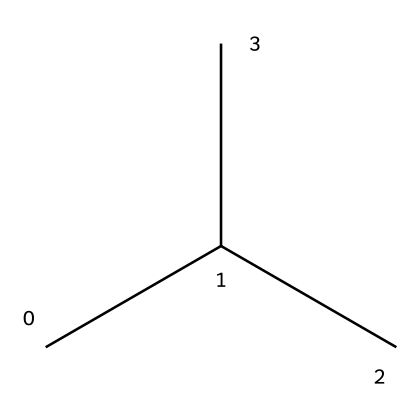What is the type of polymer represented by this chemical structure? The structure indicates it is polypropylene, which is a common type of polyolefin polymer. The branched alkyl structure suggests it can form a thermoplastic, typical of polypropylene.
Answer: polypropylene How many carbon atoms are present in this molecular structure? By analyzing the SMILES representation, "CC(C)C," it can be seen that there are four carbon atoms total. The "C" represents carbon, and counting shows four present.
Answer: four What type of bond predominates in this structure? The structure consists primarily of carbon-carbon single bonds, as shown by the connectivity in the SMILES representation, where 'C-C' bonds link the carbon atoms.
Answer: single bonds Is this polymer hydrophobic or hydrophilic? The hydrophobicity of polypropylene is due to its hydrocarbon nature, meaning it doesn't attract water molecules and thus is classified as hydrophobic.
Answer: hydrophobic What is the significance of the branched structure in polypropylene? The branched structure affects the crystallinity and, therefore, the physical properties such as melting temperature and mechanical strength of the polymer. In this case, the branches reduce crystallinity compared to linear forms.
Answer: affects crystallinity What properties can be inferred about the plastic's thermal resistance from its structure? Given the structure of polypropylene with its hydrocarbon chains and the presence of only single bonds, it typically exhibits good thermal resistance due to its stable chain configuration when heated, allowing it to resist deformation.
Answer: good thermal resistance 